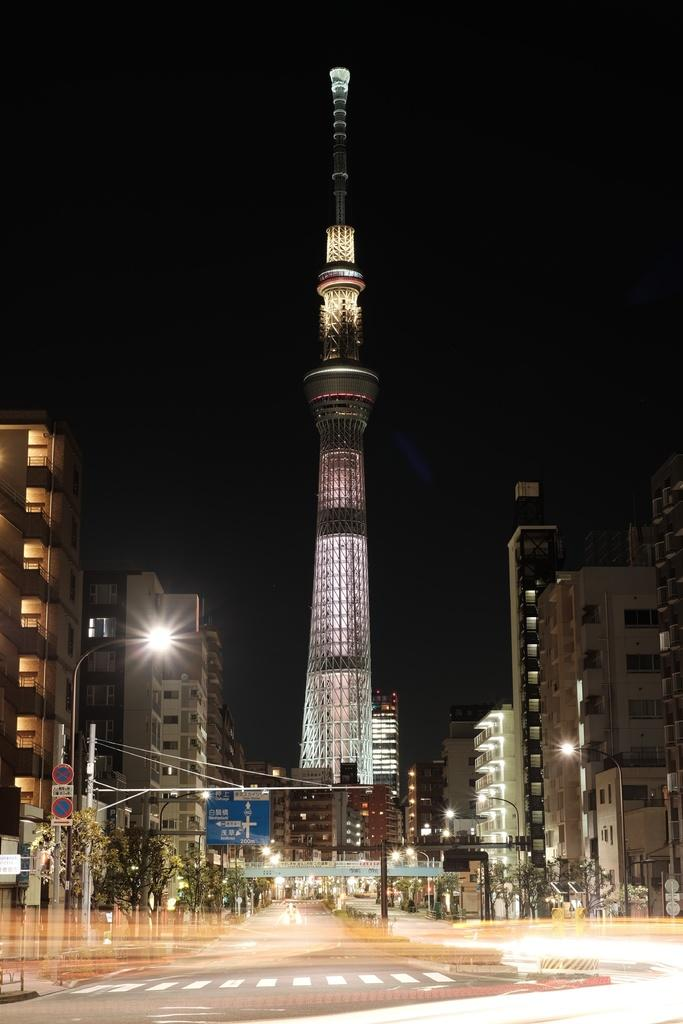What type of structures can be seen in the image? There are buildings and a tower in the image. What other objects can be seen in the image? There are poles, sign boards, lights, and trees in the image. What is at the bottom of the image? There is a road at the bottom of the image. What can be seen on the road? There are white lines on the road. How would you describe the background of the image? The background of the image is dark. What flavor of sponge is being used to clean the tower in the image? There is no sponge or cleaning activity depicted in the image. Is there a railway visible in the image? No, there is no railway present in the image. 